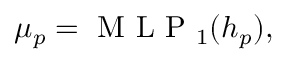<formula> <loc_0><loc_0><loc_500><loc_500>\begin{array} { r } { \begin{array} { r } { \mu _ { p } = M L P _ { 1 } ( h _ { p } ) , } \end{array} } \end{array}</formula> 